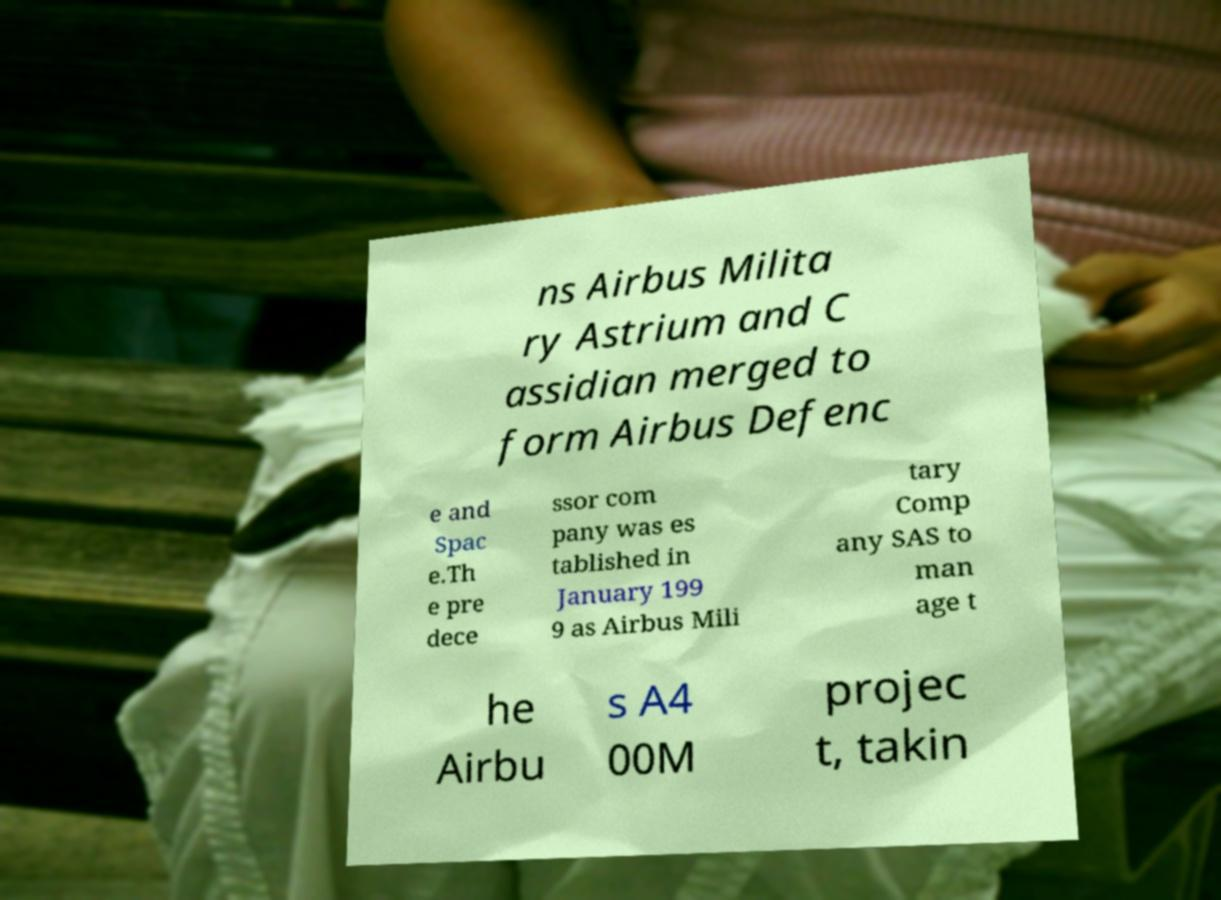Could you assist in decoding the text presented in this image and type it out clearly? ns Airbus Milita ry Astrium and C assidian merged to form Airbus Defenc e and Spac e.Th e pre dece ssor com pany was es tablished in January 199 9 as Airbus Mili tary Comp any SAS to man age t he Airbu s A4 00M projec t, takin 